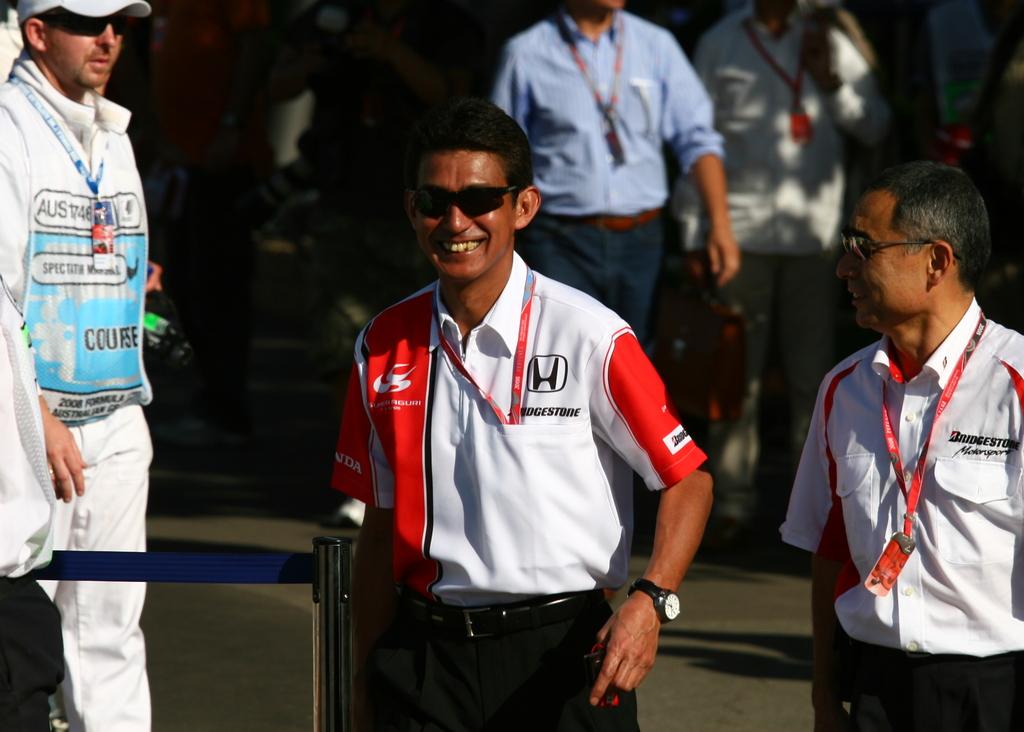What does the right most man's shirt say over the pocket?
Provide a succinct answer. Bridgestone. What letter is shown in the square on the man's shirt?
Make the answer very short. H. 